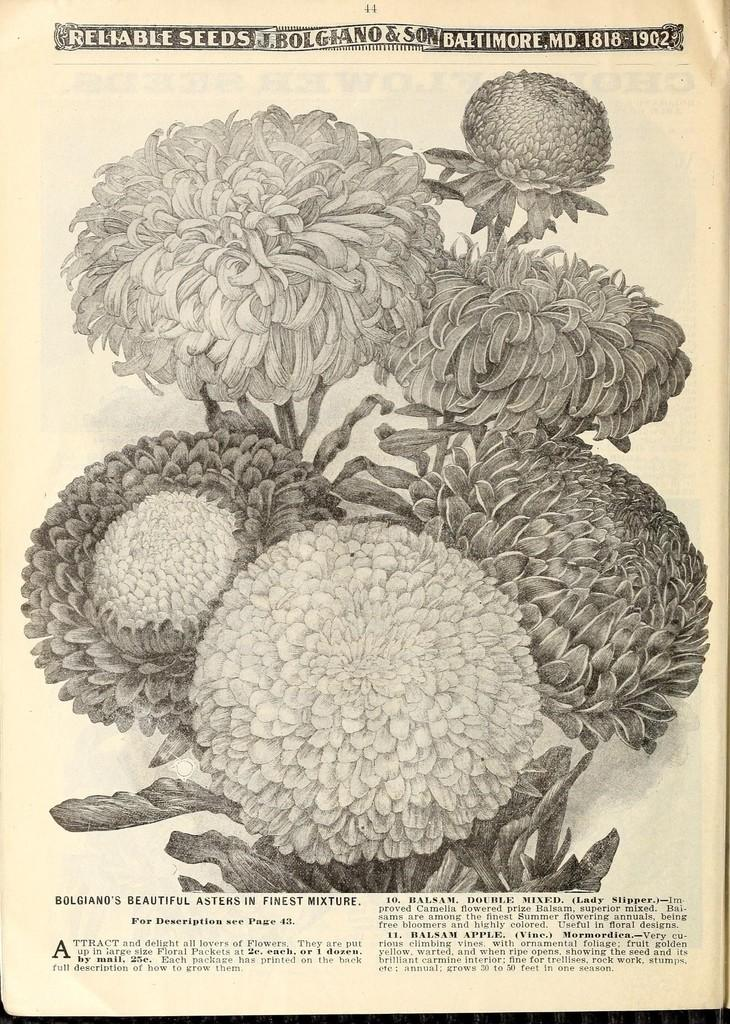What is the main subject of the paper in the image? The paper contains diagrams of flowers. What else can be found on the paper besides the diagrams? There is text present on the paper. What type of soda is being poured into the diagram of a flower on the paper? There is no soda present in the image; it only features a paper with diagrams of flowers and text. 